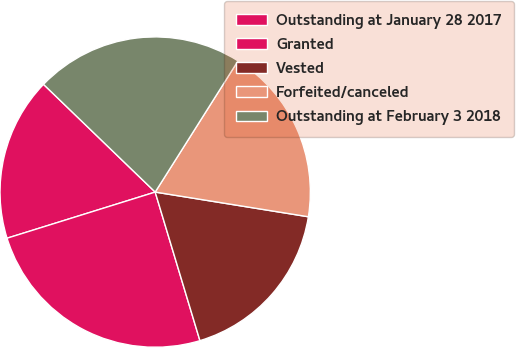Convert chart. <chart><loc_0><loc_0><loc_500><loc_500><pie_chart><fcel>Outstanding at January 28 2017<fcel>Granted<fcel>Vested<fcel>Forfeited/canceled<fcel>Outstanding at February 3 2018<nl><fcel>17.02%<fcel>24.85%<fcel>17.8%<fcel>18.58%<fcel>21.75%<nl></chart> 